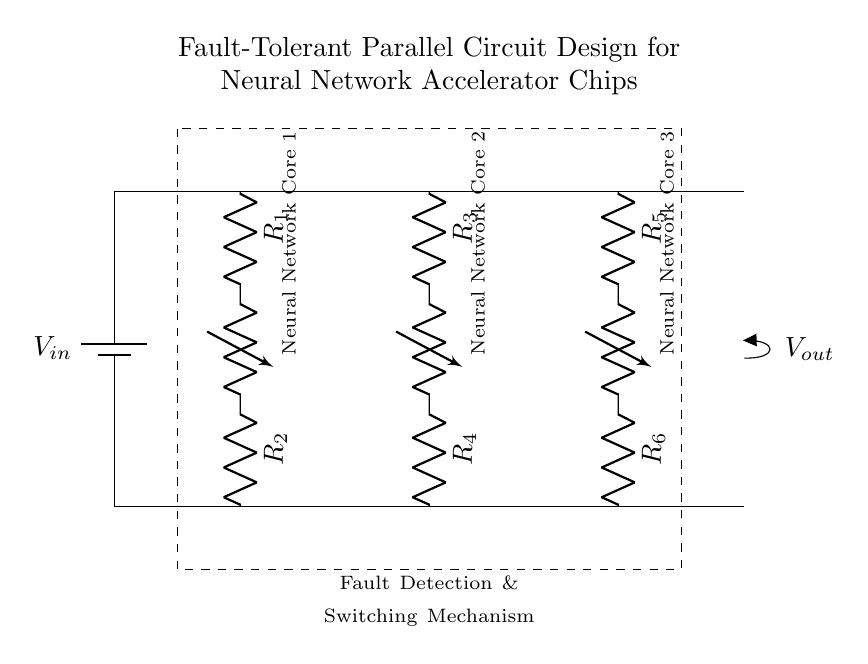What is the input voltage of the circuit? The circuit specifies $V_{in}$ as the input voltage, indicated by the battery symbol at the beginning of the circuit.
Answer: $V_{in}$ How many neural network cores are present in this circuit? The diagram clearly shows three branches, each labeled as a different neural network core, thus indicating there are a total of three cores in parallel.
Answer: 3 What function does the dashed rectangle represent? The dashed rectangle encloses the area labeled "Fault Detection & Switching Mechanism", denoting its function as a protective feature in the circuit design.
Answer: Fault Detection & Switching Mechanism What connects to the output node? The output node is connected to the last terminal of the parallel arrangement, where it indicates the output voltage, $V_{out}$, coming from the parallel components.
Answer: $V_{out}$ What type of circuit design is illustrated here? The circuit is arranged in a parallel configuration, evidenced by the parallel connections and the definition of multiple branches for the neural network cores.
Answer: Parallel Why is a fault detection mechanism used in this design? The inclusion of a fault detection mechanism is critical for monitoring and ensuring reliability in parallel circuits, where failure in one branch does not affect the overall performance of the system.
Answer: To ensure reliability What is the role of resistors in this circuit? Each branch has resistors connected in series with the neural network cores, which helps limit current and manage heat generation, indicating their importance in circuit functioning.
Answer: Current limiting 